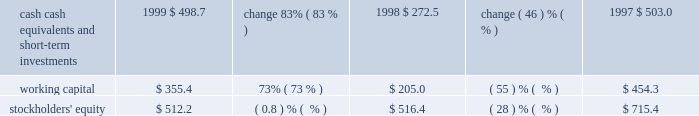Liquidity and capital resources .
Our cash , cash equivalents , and short-term investments consist principally of money market mutual funds , municipal bonds , and united states government agency securities .
All of our cash equivalents and short-term investments are classified as available-for-sale under the provisions of sfas 115 , 2018 2018accounting for certain investments in debt and equity securities . 2019 2019 the securities are carried at fair value with the unrealized gains and losses , net of tax , included in accumulated other comprehensive income , which is reflected as a separate component of stockholders 2019 equity .
Our cash , cash equivalents , and short-term investments increased $ 226.2 million , or 83% ( 83 % ) , in fiscal 1999 , primarily due to cash generated from operations of $ 334.2 million , proceeds from the issuance of treasury stock related to the exercise of stock options under our stock option plans and sale of stock under the employee stock purchase plan of $ 142.9 million , and the release of restricted funds totaling $ 130.3 million associated with the refinancing of our corporate headquarters lease agreement .
Other sources of cash include the proceeds from the sale of equity securities and the sale of a building in the amount of $ 63.9 million and $ 40.6 million , respectively .
In addition , short-term investments increased due to a reclassification of $ 46.7 million of investments classified as long-term to short-term as well as mark-to-market adjustments totaling $ 81.2 million .
These factors were partially offset by the purchase of treasury stock in the amount of $ 479.2 million , capital expenditures of $ 42.2 million , the purchase of other assets for $ 43.5 million , the purchase of the assets of golive systems and attitude software for $ 36.9 million , and the payment of dividends totaling $ 12.2 million .
We expect to continue our investing activities , including expenditures for computer systems for research and development , sales and marketing , product support , and administrative staff .
Furthermore , cash reserves may be used to purchase treasury stock and acquire software companies , products , or technologies that are complementary to our business .
In september 1997 , adobe 2019s board of directors authorized , subject to certain business and market conditions , the purchase of up to 30.0 million shares of our common stock over a two-year period .
We repurchased approximately 1.7 million shares in the first quarter of fiscal 1999 , 20.3 million shares in fiscal 1998 , and 8.0 million shares in fiscal 1997 , at a cost of $ 30.5 million , $ 362.4 million , and $ 188.6 million , respectively .
This program was completed during the first quarter of fiscal 1999 .
In april 1999 , adobe 2019s board of directors authorized , subject to certain business and market conditions , the purchase of up to an additional 5.0 million shares of our common stock over a two-year period .
This new stock repurchase program was in addition to an existing program whereby we have been authorized to repurchase shares to offset issuances under employee stock option and stock purchase plans .
No purchases have been made under the 5.0 million share repurchase program .
Under our existing plan to repurchase shares to offset issuances under employee stock plans , we repurchased approximately 11.2 million , 0.7 million , and 4.6 million shares in fiscal 1999 , 1998 , and 1997 , respectively , at a cost of $ 448.7 million , $ 16.8 million , and $ 87.0 million , respectively .
We have paid cash dividends on our common stock each quarter since the second quarter of 1988 .
Adobe 2019s board of directors declared a cash dividend on our common stock of $ 0.025 per common share for each of the four quarters in fiscal 1999 , 1998 , and 1997 .
On december 1 , 1997 , we dividended one share of siebel common stock for each 600 shares of adobe common stock held by stockholders of record on october 31 , 1997 .
An equivalent cash dividend was paid for holdings of less than 15000 adobe shares and .
What is the average purchase price of shares purchased during 1999? 
Computations: (30.5 / 1.7)
Answer: 17.94118. Liquidity and capital resources .
Our cash , cash equivalents , and short-term investments consist principally of money market mutual funds , municipal bonds , and united states government agency securities .
All of our cash equivalents and short-term investments are classified as available-for-sale under the provisions of sfas 115 , 2018 2018accounting for certain investments in debt and equity securities . 2019 2019 the securities are carried at fair value with the unrealized gains and losses , net of tax , included in accumulated other comprehensive income , which is reflected as a separate component of stockholders 2019 equity .
Our cash , cash equivalents , and short-term investments increased $ 226.2 million , or 83% ( 83 % ) , in fiscal 1999 , primarily due to cash generated from operations of $ 334.2 million , proceeds from the issuance of treasury stock related to the exercise of stock options under our stock option plans and sale of stock under the employee stock purchase plan of $ 142.9 million , and the release of restricted funds totaling $ 130.3 million associated with the refinancing of our corporate headquarters lease agreement .
Other sources of cash include the proceeds from the sale of equity securities and the sale of a building in the amount of $ 63.9 million and $ 40.6 million , respectively .
In addition , short-term investments increased due to a reclassification of $ 46.7 million of investments classified as long-term to short-term as well as mark-to-market adjustments totaling $ 81.2 million .
These factors were partially offset by the purchase of treasury stock in the amount of $ 479.2 million , capital expenditures of $ 42.2 million , the purchase of other assets for $ 43.5 million , the purchase of the assets of golive systems and attitude software for $ 36.9 million , and the payment of dividends totaling $ 12.2 million .
We expect to continue our investing activities , including expenditures for computer systems for research and development , sales and marketing , product support , and administrative staff .
Furthermore , cash reserves may be used to purchase treasury stock and acquire software companies , products , or technologies that are complementary to our business .
In september 1997 , adobe 2019s board of directors authorized , subject to certain business and market conditions , the purchase of up to 30.0 million shares of our common stock over a two-year period .
We repurchased approximately 1.7 million shares in the first quarter of fiscal 1999 , 20.3 million shares in fiscal 1998 , and 8.0 million shares in fiscal 1997 , at a cost of $ 30.5 million , $ 362.4 million , and $ 188.6 million , respectively .
This program was completed during the first quarter of fiscal 1999 .
In april 1999 , adobe 2019s board of directors authorized , subject to certain business and market conditions , the purchase of up to an additional 5.0 million shares of our common stock over a two-year period .
This new stock repurchase program was in addition to an existing program whereby we have been authorized to repurchase shares to offset issuances under employee stock option and stock purchase plans .
No purchases have been made under the 5.0 million share repurchase program .
Under our existing plan to repurchase shares to offset issuances under employee stock plans , we repurchased approximately 11.2 million , 0.7 million , and 4.6 million shares in fiscal 1999 , 1998 , and 1997 , respectively , at a cost of $ 448.7 million , $ 16.8 million , and $ 87.0 million , respectively .
We have paid cash dividends on our common stock each quarter since the second quarter of 1988 .
Adobe 2019s board of directors declared a cash dividend on our common stock of $ 0.025 per common share for each of the four quarters in fiscal 1999 , 1998 , and 1997 .
On december 1 , 1997 , we dividended one share of siebel common stock for each 600 shares of adobe common stock held by stockholders of record on october 31 , 1997 .
An equivalent cash dividend was paid for holdings of less than 15000 adobe shares and .
What is the average purchase price of shares purchased during 1998? 
Computations: (362.4 / 20.3)
Answer: 17.85222. 